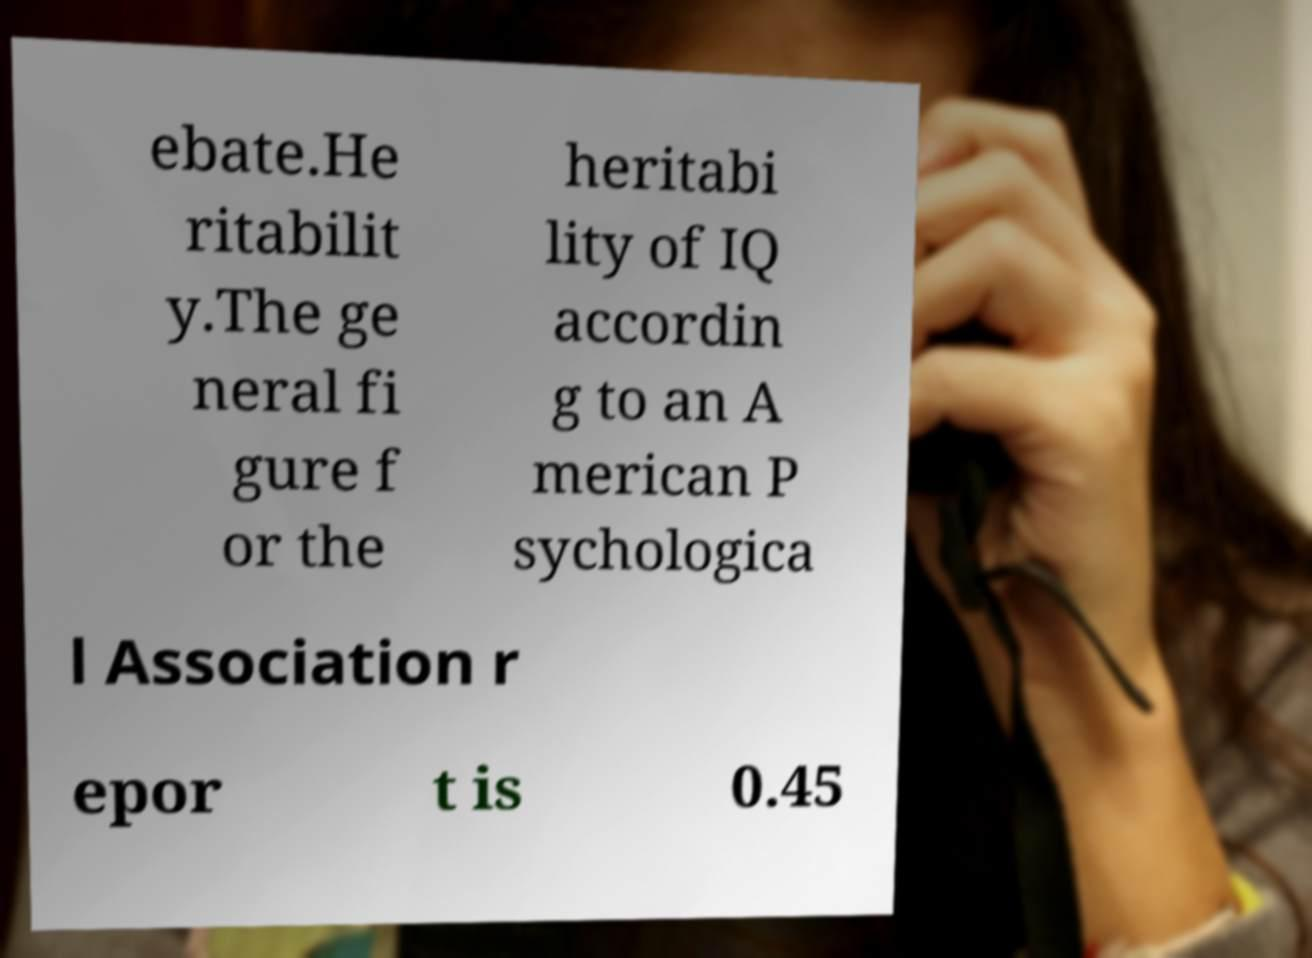Could you assist in decoding the text presented in this image and type it out clearly? ebate.He ritabilit y.The ge neral fi gure f or the heritabi lity of IQ accordin g to an A merican P sychologica l Association r epor t is 0.45 